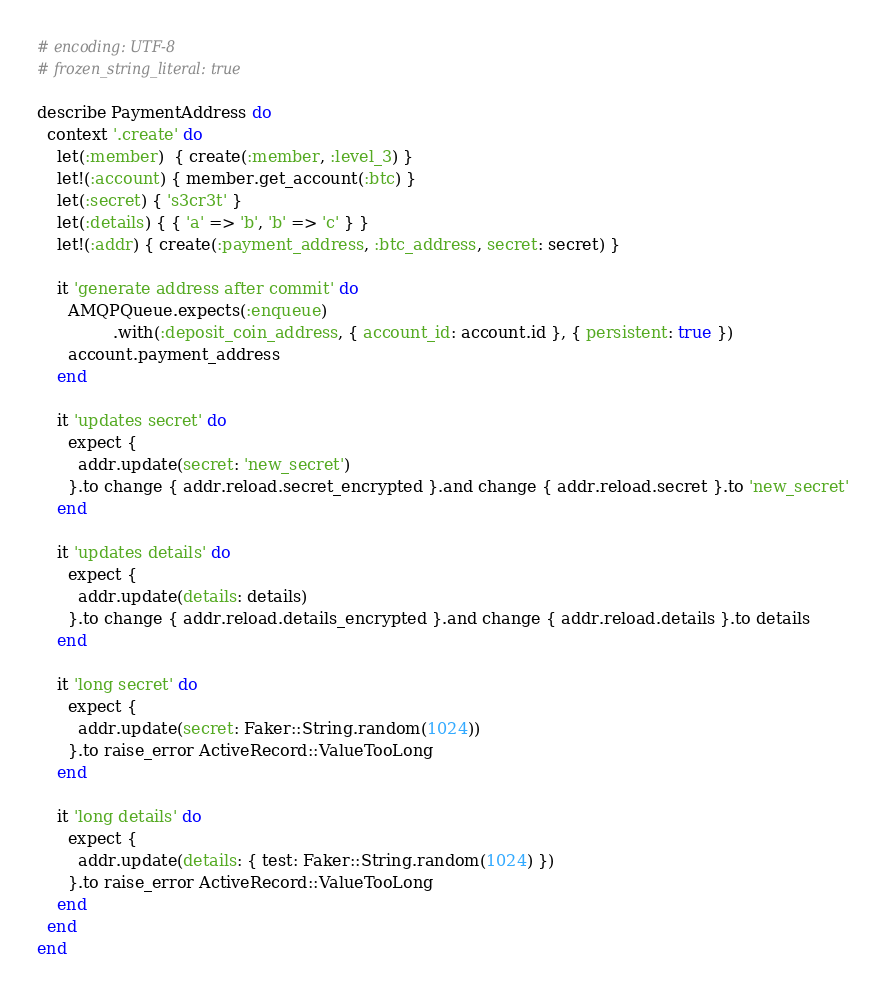<code> <loc_0><loc_0><loc_500><loc_500><_Ruby_># encoding: UTF-8
# frozen_string_literal: true

describe PaymentAddress do
  context '.create' do
    let(:member)  { create(:member, :level_3) }
    let!(:account) { member.get_account(:btc) }
    let(:secret) { 's3cr3t' }
    let(:details) { { 'a' => 'b', 'b' => 'c' } }
    let!(:addr) { create(:payment_address, :btc_address, secret: secret) }

    it 'generate address after commit' do
      AMQPQueue.expects(:enqueue)
               .with(:deposit_coin_address, { account_id: account.id }, { persistent: true })
      account.payment_address
    end

    it 'updates secret' do
      expect {
        addr.update(secret: 'new_secret')
      }.to change { addr.reload.secret_encrypted }.and change { addr.reload.secret }.to 'new_secret'
    end

    it 'updates details' do
      expect {
        addr.update(details: details)
      }.to change { addr.reload.details_encrypted }.and change { addr.reload.details }.to details
    end

    it 'long secret' do
      expect {
        addr.update(secret: Faker::String.random(1024))
      }.to raise_error ActiveRecord::ValueTooLong
    end

    it 'long details' do
      expect {
        addr.update(details: { test: Faker::String.random(1024) })
      }.to raise_error ActiveRecord::ValueTooLong
    end
  end
end
</code> 